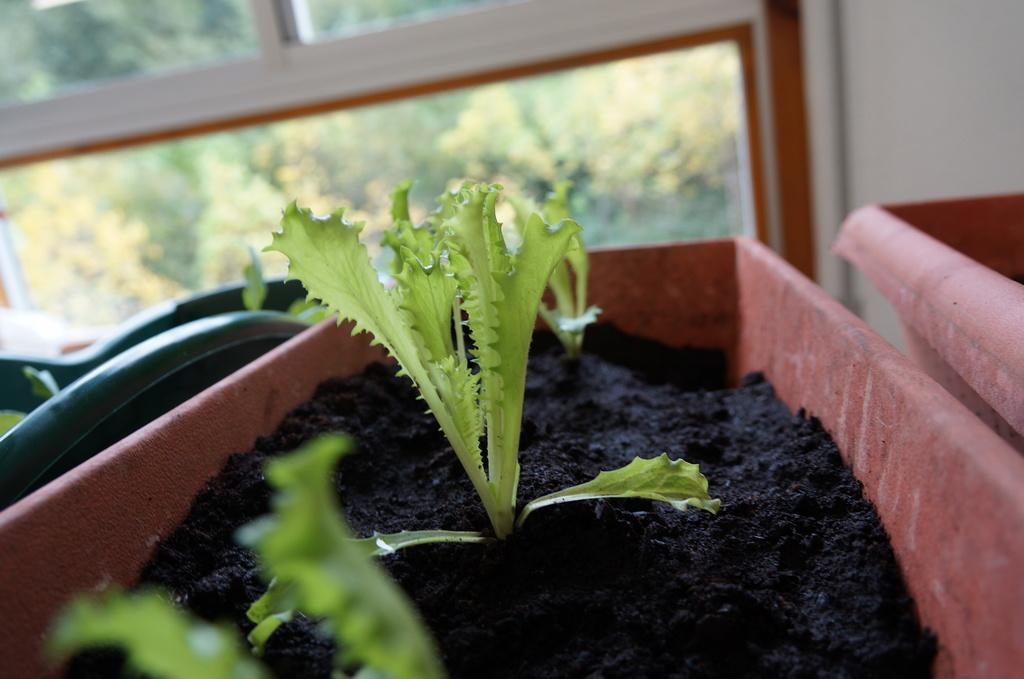What type of plants are in the image? There are plants in a pot in the image. What can be seen through the window in the image? The image does not show what can be seen through the window. What is visible on the wall in the image? The image does not show any specific details about the wall. What type of bells can be heard ringing during the son's recess in the image? There is no son, recess, or bells present in the image. 